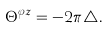Convert formula to latex. <formula><loc_0><loc_0><loc_500><loc_500>\Theta ^ { \varphi z } = - 2 \pi \triangle .</formula> 